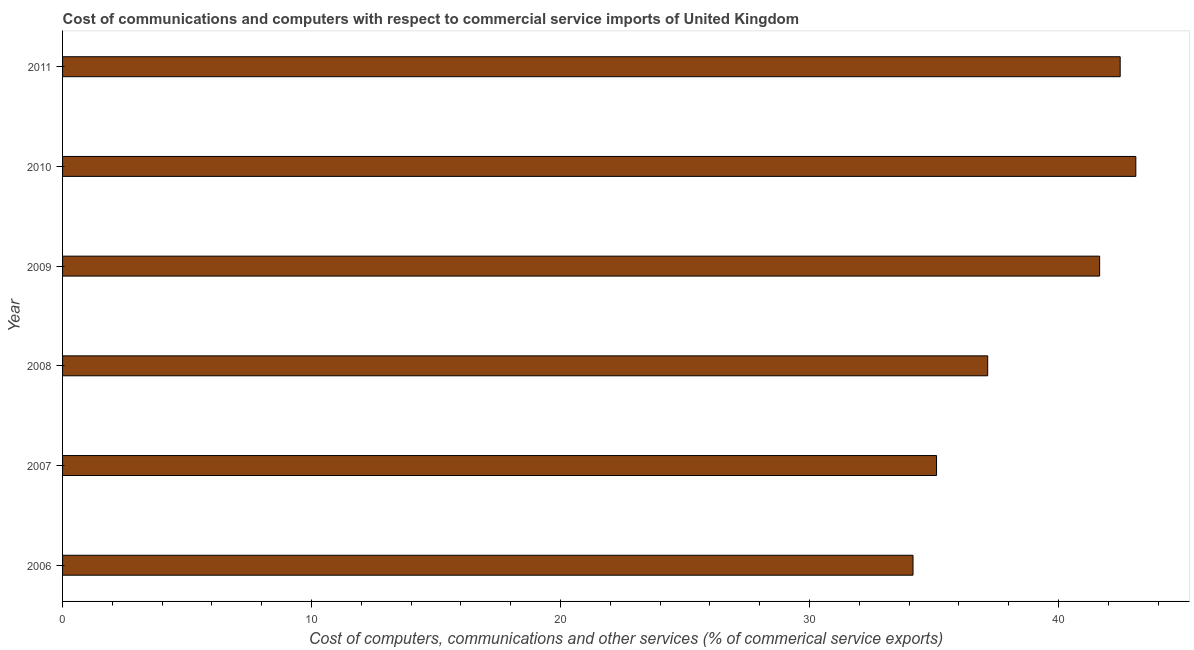Does the graph contain grids?
Your answer should be compact. No. What is the title of the graph?
Provide a short and direct response. Cost of communications and computers with respect to commercial service imports of United Kingdom. What is the label or title of the X-axis?
Your response must be concise. Cost of computers, communications and other services (% of commerical service exports). What is the label or title of the Y-axis?
Make the answer very short. Year. What is the cost of communications in 2007?
Offer a very short reply. 35.1. Across all years, what is the maximum cost of communications?
Make the answer very short. 43.11. Across all years, what is the minimum cost of communications?
Your answer should be compact. 34.16. What is the sum of the  computer and other services?
Ensure brevity in your answer.  233.65. What is the difference between the cost of communications in 2006 and 2011?
Ensure brevity in your answer.  -8.32. What is the average cost of communications per year?
Provide a short and direct response. 38.94. What is the median  computer and other services?
Provide a short and direct response. 39.4. What is the ratio of the  computer and other services in 2006 to that in 2008?
Give a very brief answer. 0.92. What is the difference between the highest and the second highest  computer and other services?
Provide a succinct answer. 0.63. What is the difference between the highest and the lowest  computer and other services?
Your response must be concise. 8.95. In how many years, is the  computer and other services greater than the average  computer and other services taken over all years?
Provide a short and direct response. 3. How many bars are there?
Give a very brief answer. 6. What is the difference between two consecutive major ticks on the X-axis?
Provide a short and direct response. 10. What is the Cost of computers, communications and other services (% of commerical service exports) of 2006?
Offer a very short reply. 34.16. What is the Cost of computers, communications and other services (% of commerical service exports) in 2007?
Your response must be concise. 35.1. What is the Cost of computers, communications and other services (% of commerical service exports) in 2008?
Offer a very short reply. 37.16. What is the Cost of computers, communications and other services (% of commerical service exports) of 2009?
Provide a succinct answer. 41.65. What is the Cost of computers, communications and other services (% of commerical service exports) of 2010?
Ensure brevity in your answer.  43.11. What is the Cost of computers, communications and other services (% of commerical service exports) of 2011?
Ensure brevity in your answer.  42.48. What is the difference between the Cost of computers, communications and other services (% of commerical service exports) in 2006 and 2007?
Offer a terse response. -0.95. What is the difference between the Cost of computers, communications and other services (% of commerical service exports) in 2006 and 2008?
Your response must be concise. -3. What is the difference between the Cost of computers, communications and other services (% of commerical service exports) in 2006 and 2009?
Offer a very short reply. -7.5. What is the difference between the Cost of computers, communications and other services (% of commerical service exports) in 2006 and 2010?
Provide a short and direct response. -8.95. What is the difference between the Cost of computers, communications and other services (% of commerical service exports) in 2006 and 2011?
Your answer should be compact. -8.32. What is the difference between the Cost of computers, communications and other services (% of commerical service exports) in 2007 and 2008?
Provide a short and direct response. -2.05. What is the difference between the Cost of computers, communications and other services (% of commerical service exports) in 2007 and 2009?
Give a very brief answer. -6.55. What is the difference between the Cost of computers, communications and other services (% of commerical service exports) in 2007 and 2010?
Ensure brevity in your answer.  -8. What is the difference between the Cost of computers, communications and other services (% of commerical service exports) in 2007 and 2011?
Your response must be concise. -7.38. What is the difference between the Cost of computers, communications and other services (% of commerical service exports) in 2008 and 2009?
Keep it short and to the point. -4.5. What is the difference between the Cost of computers, communications and other services (% of commerical service exports) in 2008 and 2010?
Your response must be concise. -5.95. What is the difference between the Cost of computers, communications and other services (% of commerical service exports) in 2008 and 2011?
Your response must be concise. -5.32. What is the difference between the Cost of computers, communications and other services (% of commerical service exports) in 2009 and 2010?
Provide a short and direct response. -1.45. What is the difference between the Cost of computers, communications and other services (% of commerical service exports) in 2009 and 2011?
Give a very brief answer. -0.83. What is the difference between the Cost of computers, communications and other services (% of commerical service exports) in 2010 and 2011?
Give a very brief answer. 0.63. What is the ratio of the Cost of computers, communications and other services (% of commerical service exports) in 2006 to that in 2008?
Give a very brief answer. 0.92. What is the ratio of the Cost of computers, communications and other services (% of commerical service exports) in 2006 to that in 2009?
Your answer should be compact. 0.82. What is the ratio of the Cost of computers, communications and other services (% of commerical service exports) in 2006 to that in 2010?
Provide a succinct answer. 0.79. What is the ratio of the Cost of computers, communications and other services (% of commerical service exports) in 2006 to that in 2011?
Keep it short and to the point. 0.8. What is the ratio of the Cost of computers, communications and other services (% of commerical service exports) in 2007 to that in 2008?
Your answer should be very brief. 0.94. What is the ratio of the Cost of computers, communications and other services (% of commerical service exports) in 2007 to that in 2009?
Offer a terse response. 0.84. What is the ratio of the Cost of computers, communications and other services (% of commerical service exports) in 2007 to that in 2010?
Offer a terse response. 0.81. What is the ratio of the Cost of computers, communications and other services (% of commerical service exports) in 2007 to that in 2011?
Offer a very short reply. 0.83. What is the ratio of the Cost of computers, communications and other services (% of commerical service exports) in 2008 to that in 2009?
Give a very brief answer. 0.89. What is the ratio of the Cost of computers, communications and other services (% of commerical service exports) in 2008 to that in 2010?
Your response must be concise. 0.86. What is the ratio of the Cost of computers, communications and other services (% of commerical service exports) in 2008 to that in 2011?
Keep it short and to the point. 0.88. What is the ratio of the Cost of computers, communications and other services (% of commerical service exports) in 2009 to that in 2011?
Keep it short and to the point. 0.98. What is the ratio of the Cost of computers, communications and other services (% of commerical service exports) in 2010 to that in 2011?
Give a very brief answer. 1.01. 